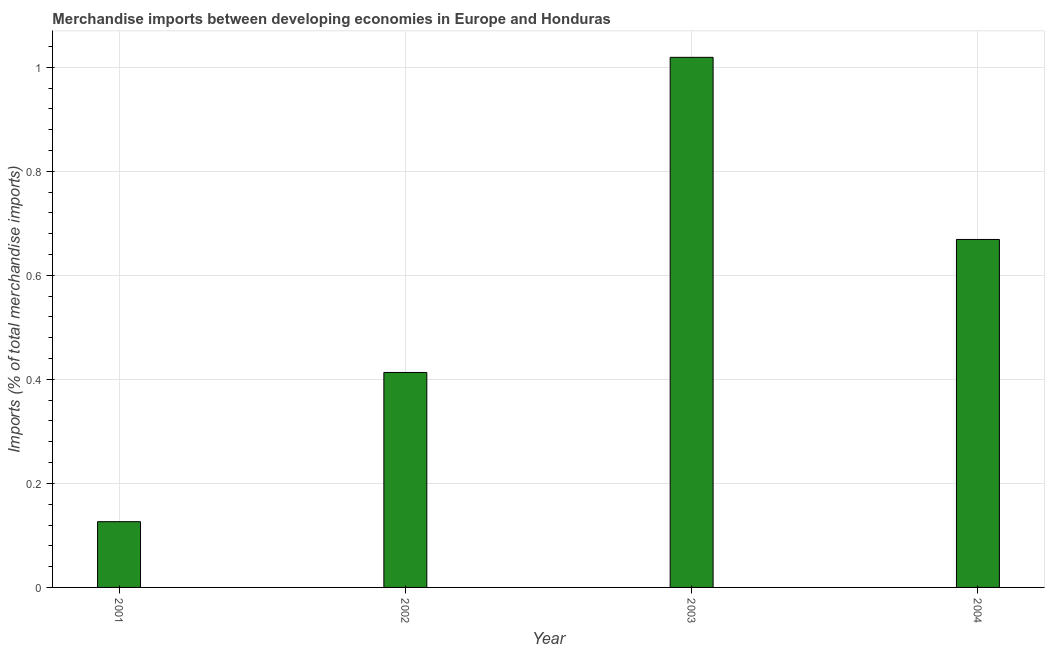Does the graph contain grids?
Ensure brevity in your answer.  Yes. What is the title of the graph?
Keep it short and to the point. Merchandise imports between developing economies in Europe and Honduras. What is the label or title of the Y-axis?
Give a very brief answer. Imports (% of total merchandise imports). What is the merchandise imports in 2003?
Give a very brief answer. 1.02. Across all years, what is the maximum merchandise imports?
Make the answer very short. 1.02. Across all years, what is the minimum merchandise imports?
Offer a terse response. 0.13. What is the sum of the merchandise imports?
Give a very brief answer. 2.23. What is the difference between the merchandise imports in 2001 and 2004?
Offer a very short reply. -0.54. What is the average merchandise imports per year?
Give a very brief answer. 0.56. What is the median merchandise imports?
Provide a succinct answer. 0.54. In how many years, is the merchandise imports greater than 0.36 %?
Provide a short and direct response. 3. What is the ratio of the merchandise imports in 2002 to that in 2003?
Keep it short and to the point. 0.41. Is the sum of the merchandise imports in 2001 and 2003 greater than the maximum merchandise imports across all years?
Make the answer very short. Yes. What is the difference between the highest and the lowest merchandise imports?
Make the answer very short. 0.89. In how many years, is the merchandise imports greater than the average merchandise imports taken over all years?
Your answer should be compact. 2. How many bars are there?
Give a very brief answer. 4. Are all the bars in the graph horizontal?
Keep it short and to the point. No. What is the difference between two consecutive major ticks on the Y-axis?
Offer a terse response. 0.2. What is the Imports (% of total merchandise imports) of 2001?
Your response must be concise. 0.13. What is the Imports (% of total merchandise imports) of 2002?
Keep it short and to the point. 0.41. What is the Imports (% of total merchandise imports) in 2003?
Offer a terse response. 1.02. What is the Imports (% of total merchandise imports) of 2004?
Your response must be concise. 0.67. What is the difference between the Imports (% of total merchandise imports) in 2001 and 2002?
Ensure brevity in your answer.  -0.29. What is the difference between the Imports (% of total merchandise imports) in 2001 and 2003?
Keep it short and to the point. -0.89. What is the difference between the Imports (% of total merchandise imports) in 2001 and 2004?
Give a very brief answer. -0.54. What is the difference between the Imports (% of total merchandise imports) in 2002 and 2003?
Your answer should be very brief. -0.61. What is the difference between the Imports (% of total merchandise imports) in 2002 and 2004?
Ensure brevity in your answer.  -0.26. What is the difference between the Imports (% of total merchandise imports) in 2003 and 2004?
Provide a short and direct response. 0.35. What is the ratio of the Imports (% of total merchandise imports) in 2001 to that in 2002?
Keep it short and to the point. 0.31. What is the ratio of the Imports (% of total merchandise imports) in 2001 to that in 2003?
Make the answer very short. 0.12. What is the ratio of the Imports (% of total merchandise imports) in 2001 to that in 2004?
Keep it short and to the point. 0.19. What is the ratio of the Imports (% of total merchandise imports) in 2002 to that in 2003?
Keep it short and to the point. 0.41. What is the ratio of the Imports (% of total merchandise imports) in 2002 to that in 2004?
Your answer should be compact. 0.62. What is the ratio of the Imports (% of total merchandise imports) in 2003 to that in 2004?
Ensure brevity in your answer.  1.52. 